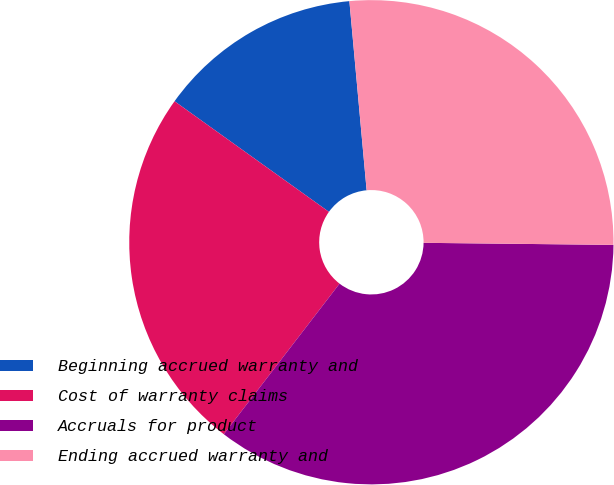Convert chart to OTSL. <chart><loc_0><loc_0><loc_500><loc_500><pie_chart><fcel>Beginning accrued warranty and<fcel>Cost of warranty claims<fcel>Accruals for product<fcel>Ending accrued warranty and<nl><fcel>13.66%<fcel>24.46%<fcel>35.26%<fcel>26.62%<nl></chart> 